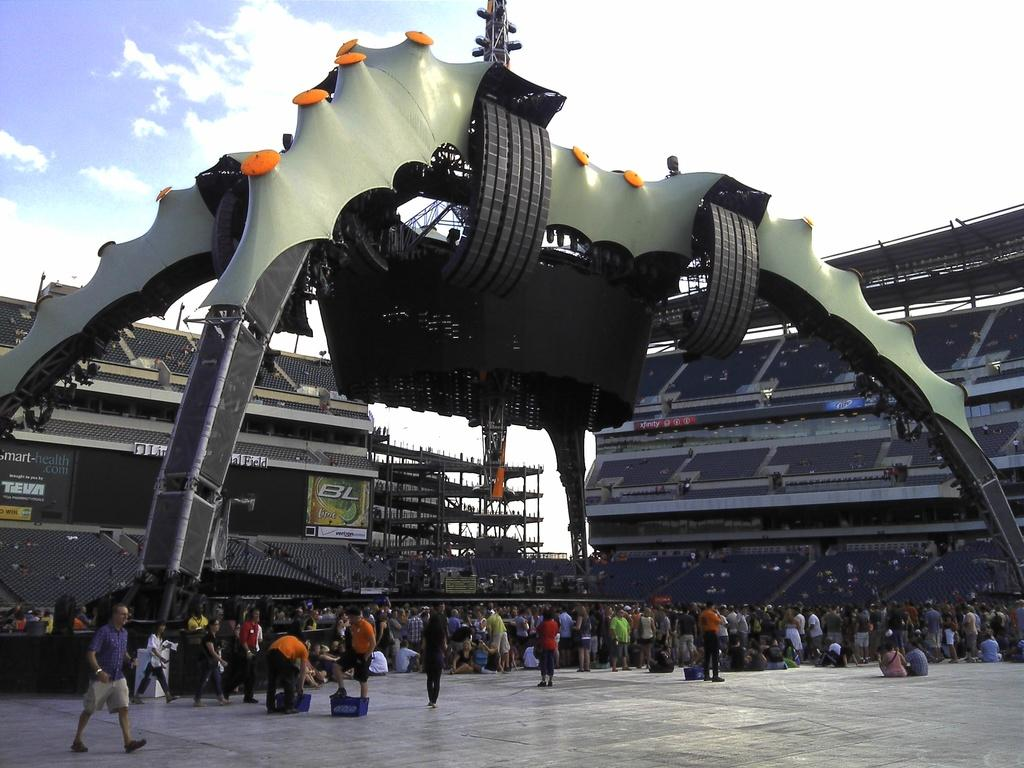What are the people in the image doing? There are persons standing and sitting in the center of the image. What can be seen in the background of the image? There are chairs and stands in the background of the image. Can you describe the stand on the top of the image? There is a stand on the top of the image. What is the weather like in the image? The sky is cloudy in the image. What type of tramp is visible in the image? There is no tramp present in the image. What advice can be given to the persons in the image? We cannot provide advice to the persons in the image, as we do not have enough information about their situation or needs. 